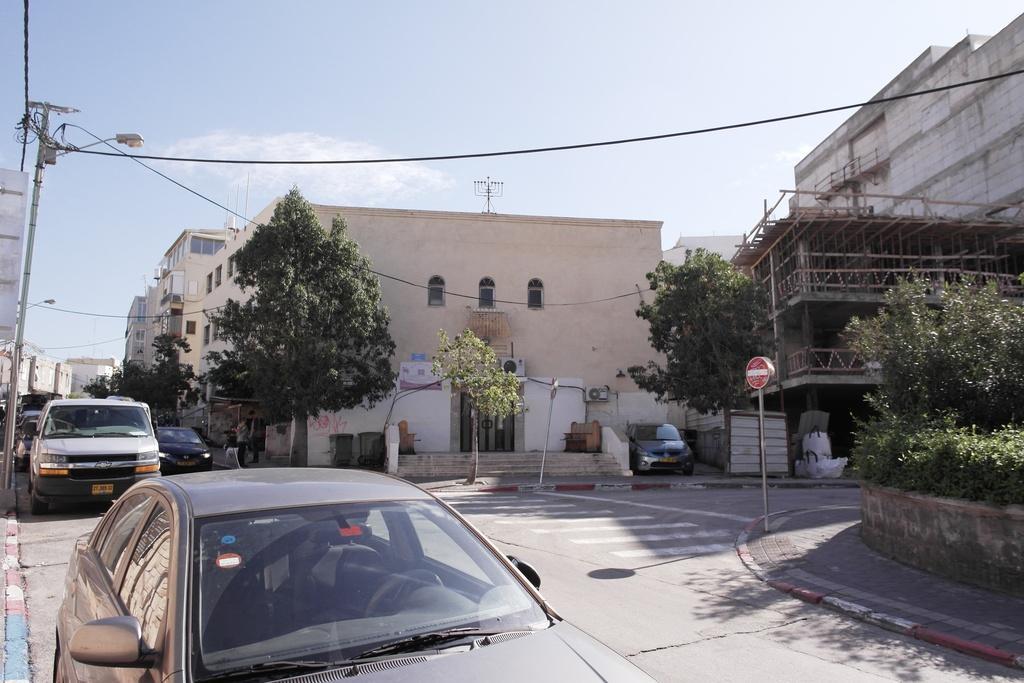In one or two sentences, can you explain what this image depicts? In this image on the road few vehicles are moving. Here there is a sign board. There are few trees over here. In the background there are buildings. Beside the road there are street lights. The sky is having few patches of clouds. 